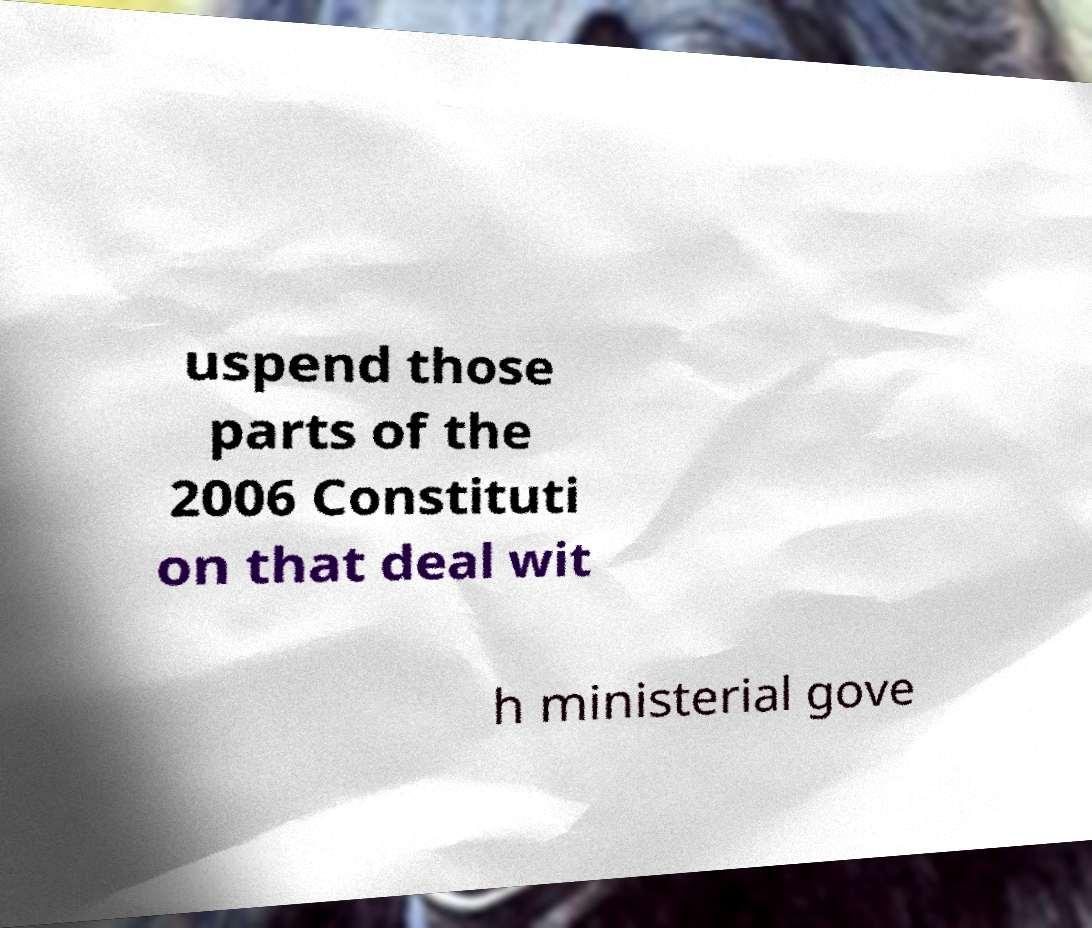Could you assist in decoding the text presented in this image and type it out clearly? uspend those parts of the 2006 Constituti on that deal wit h ministerial gove 